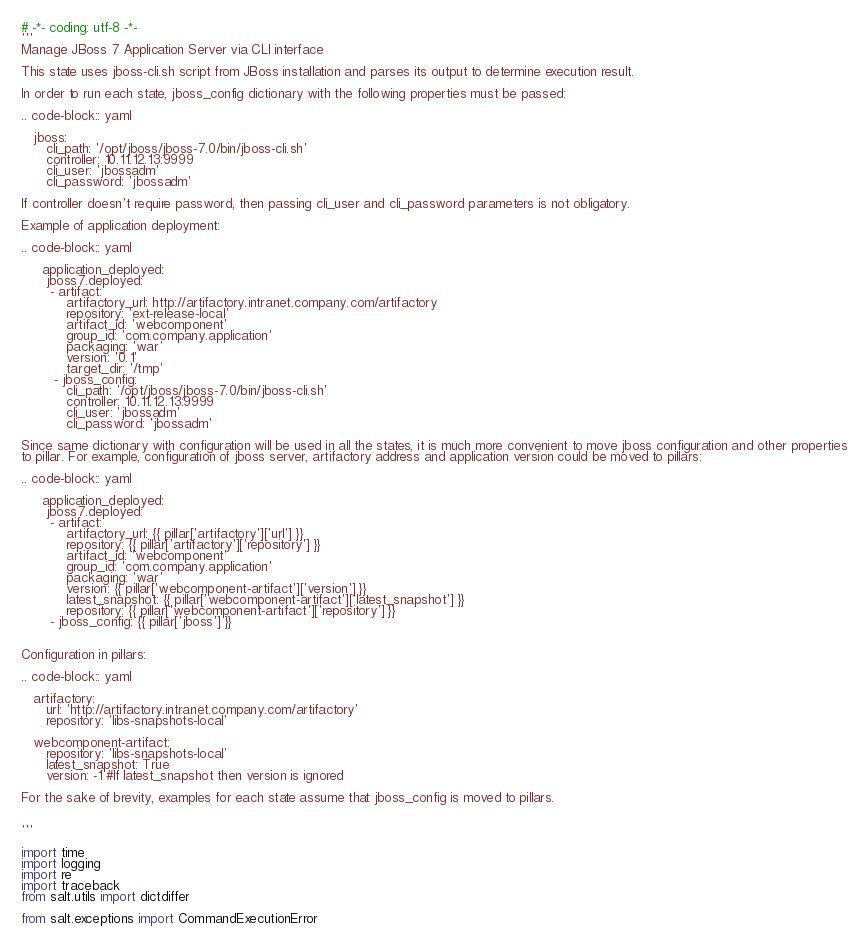<code> <loc_0><loc_0><loc_500><loc_500><_Python_># -*- coding: utf-8 -*-
'''
Manage JBoss 7 Application Server via CLI interface

This state uses jboss-cli.sh script from JBoss installation and parses its output to determine execution result.

In order to run each state, jboss_config dictionary with the following properties must be passed:

.. code-block:: yaml

   jboss:
      cli_path: '/opt/jboss/jboss-7.0/bin/jboss-cli.sh'
      controller: 10.11.12.13:9999
      cli_user: 'jbossadm'
      cli_password: 'jbossadm'

If controller doesn't require password, then passing cli_user and cli_password parameters is not obligatory.

Example of application deployment:

.. code-block:: yaml

     application_deployed:
      jboss7.deployed:
       - artifact:
           artifactory_url: http://artifactory.intranet.company.com/artifactory
           repository: 'ext-release-local'
           artifact_id: 'webcomponent'
           group_id: 'com.company.application'
           packaging: 'war'
           version: '0.1'
           target_dir: '/tmp'
        - jboss_config:
           cli_path: '/opt/jboss/jboss-7.0/bin/jboss-cli.sh'
           controller: 10.11.12.13:9999
           cli_user: 'jbossadm'
           cli_password: 'jbossadm'

Since same dictionary with configuration will be used in all the states, it is much more convenient to move jboss configuration and other properties
to pillar. For example, configuration of jboss server, artifactory address and application version could be moved to pillars:

.. code-block:: yaml

     application_deployed:
      jboss7.deployed:
       - artifact:
           artifactory_url: {{ pillar['artifactory']['url'] }}
           repository: {{ pillar['artifactory']['repository'] }}
           artifact_id: 'webcomponent'
           group_id: 'com.company.application'
           packaging: 'war'
           version: {{ pillar['webcomponent-artifact']['version'] }}
           latest_snapshot: {{ pillar['webcomponent-artifact']['latest_snapshot'] }}
           repository: {{ pillar['webcomponent-artifact']['repository'] }}
       - jboss_config: {{ pillar['jboss'] }}


Configuration in pillars:

.. code-block:: yaml

   artifactory:
      url: 'http://artifactory.intranet.company.com/artifactory'
      repository: 'libs-snapshots-local'

   webcomponent-artifact:
      repository: 'libs-snapshots-local'
      latest_snapshot: True
      version: -1 #If latest_snapshot then version is ignored

For the sake of brevity, examples for each state assume that jboss_config is moved to pillars.


'''

import time
import logging
import re
import traceback
from salt.utils import dictdiffer

from salt.exceptions import CommandExecutionError
</code> 